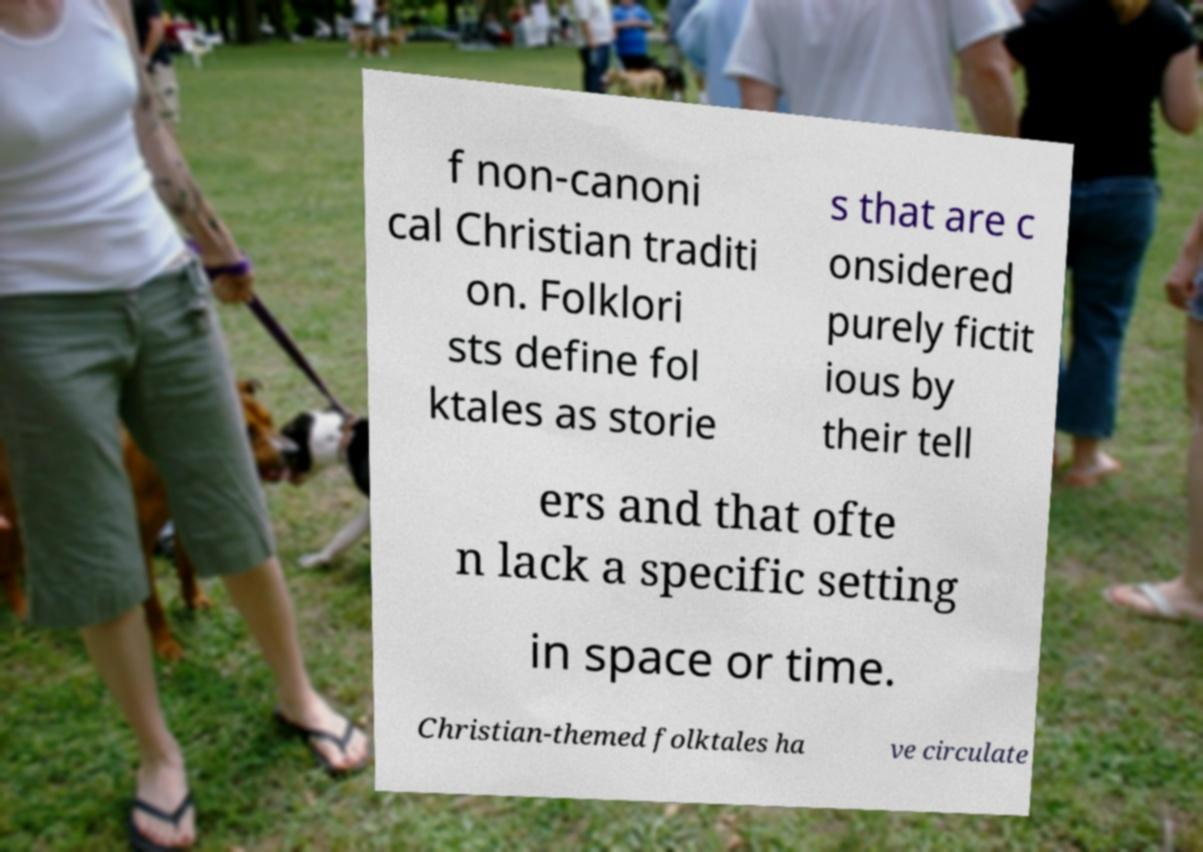Could you assist in decoding the text presented in this image and type it out clearly? f non-canoni cal Christian traditi on. Folklori sts define fol ktales as storie s that are c onsidered purely fictit ious by their tell ers and that ofte n lack a specific setting in space or time. Christian-themed folktales ha ve circulate 